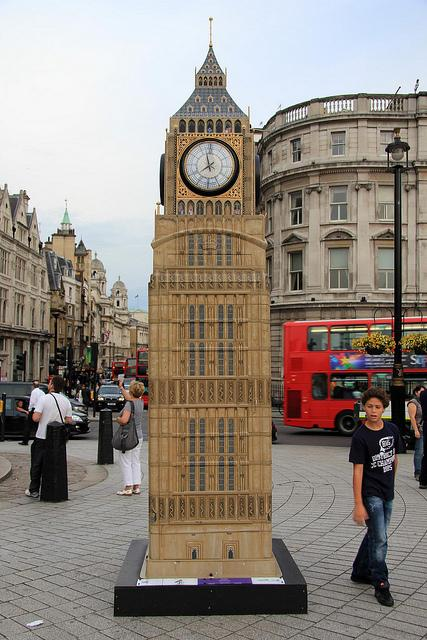What is actually the tallest object in the picture? building 